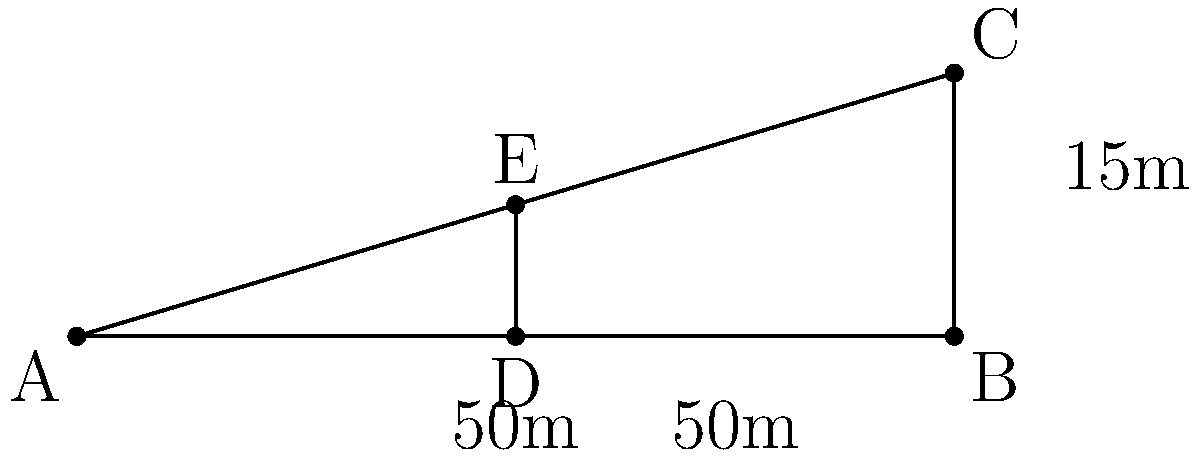As you prepare for your next motivational speech, you notice a billboard promoting your latest self-help book. The billboard is 15 meters tall and 100 meters away. If you move 50 meters closer, how much does the angle of elevation to the top of the billboard increase? Round your answer to the nearest degree. Let's approach this step-by-step:

1) First, we need to calculate the initial angle of elevation ($\theta_1$):
   $\tan(\theta_1) = \frac{\text{opposite}}{\text{adjacent}} = \frac{15}{100} = 0.15$
   $\theta_1 = \arctan(0.15) \approx 8.53°$

2) Now, let's calculate the new angle of elevation ($\theta_2$) after moving 50 meters closer:
   $\tan(\theta_2) = \frac{\text{opposite}}{\text{adjacent}} = \frac{15}{50} = 0.3$
   $\theta_2 = \arctan(0.3) \approx 16.70°$

3) The increase in the angle of elevation is:
   $\Delta\theta = \theta_2 - \theta_1 = 16.70° - 8.53° = 8.17°$

4) Rounding to the nearest degree:
   $8.17° \approx 8°$

This increase in angle represents how much more you need to elevate your gaze to see the top of the billboard after moving closer, which could be a metaphor for how perspective changes can affect our view of goals and achievements.
Answer: $8°$ 